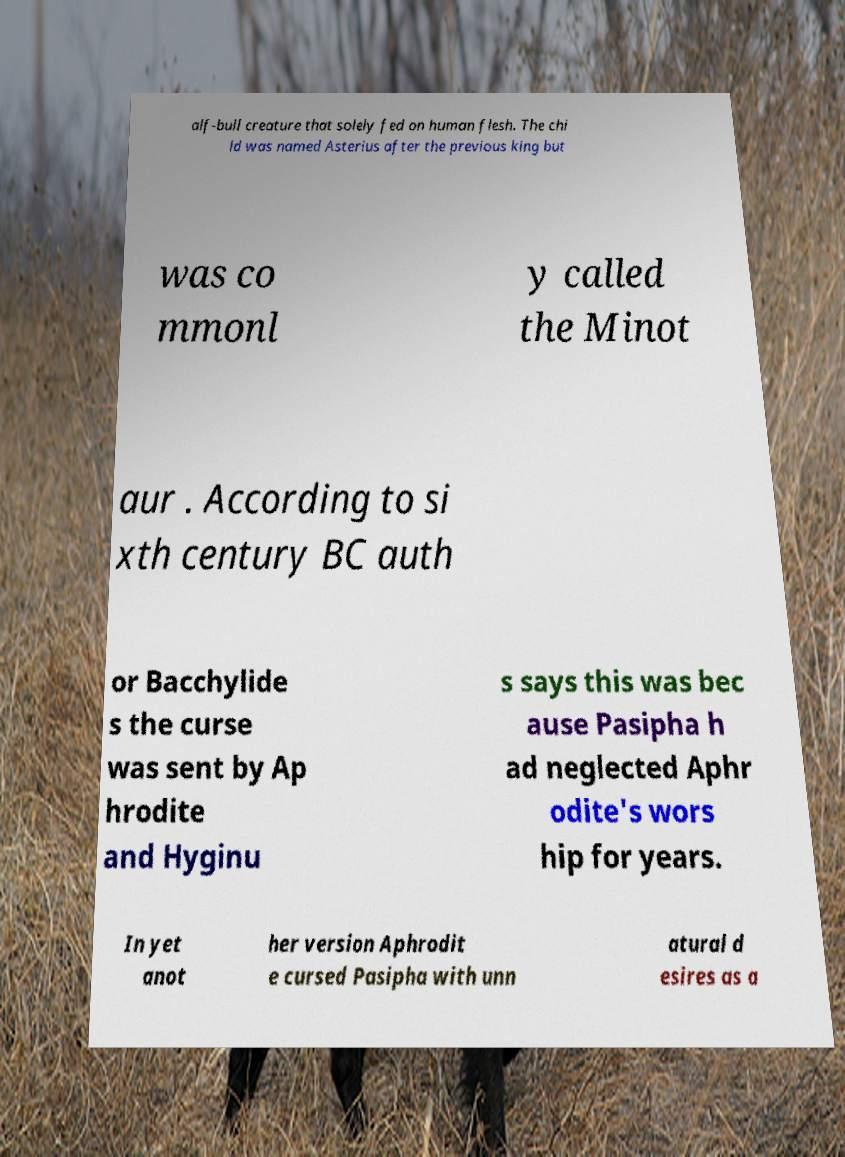Please read and relay the text visible in this image. What does it say? alf-bull creature that solely fed on human flesh. The chi ld was named Asterius after the previous king but was co mmonl y called the Minot aur . According to si xth century BC auth or Bacchylide s the curse was sent by Ap hrodite and Hyginu s says this was bec ause Pasipha h ad neglected Aphr odite's wors hip for years. In yet anot her version Aphrodit e cursed Pasipha with unn atural d esires as a 